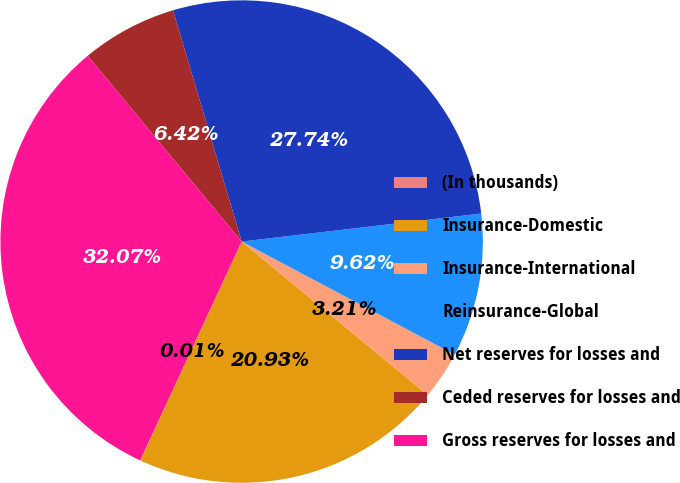Convert chart. <chart><loc_0><loc_0><loc_500><loc_500><pie_chart><fcel>(In thousands)<fcel>Insurance-Domestic<fcel>Insurance-International<fcel>Reinsurance-Global<fcel>Net reserves for losses and<fcel>Ceded reserves for losses and<fcel>Gross reserves for losses and<nl><fcel>0.01%<fcel>20.93%<fcel>3.21%<fcel>9.62%<fcel>27.74%<fcel>6.42%<fcel>32.07%<nl></chart> 